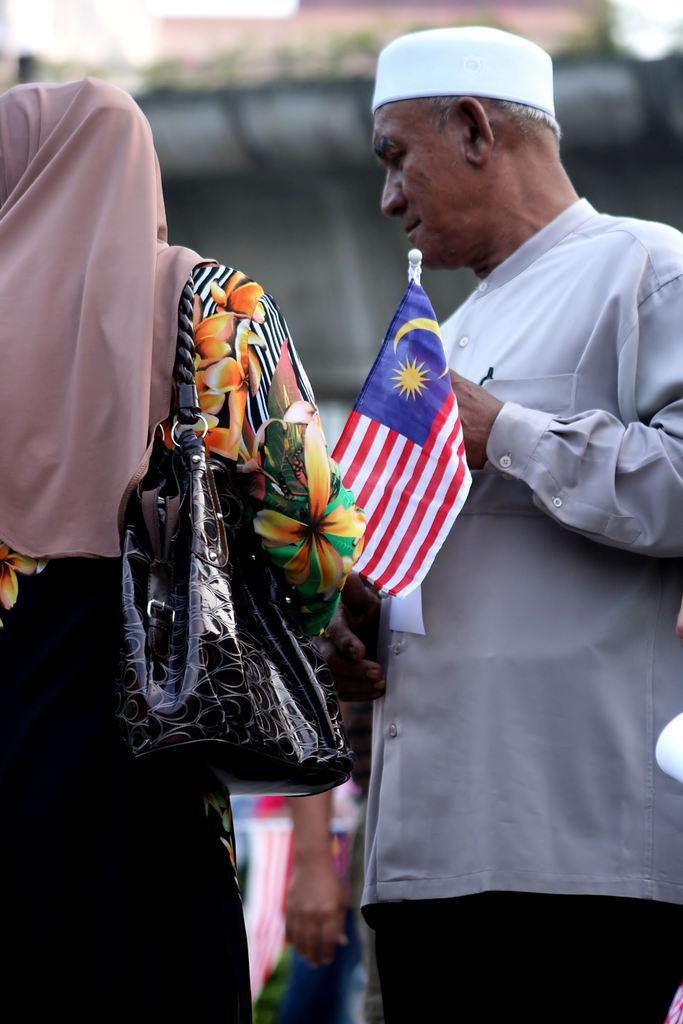Describe this image in one or two sentences. In this image there is a man and a woman standing. The woman is wearing a handbag. The man is holding a flag in his hand. the background is blurry. At the bottom there is a hand of a person behind them. 